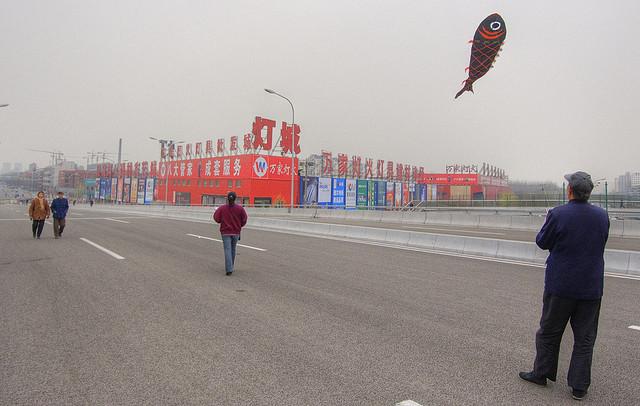Are there any people in the street?
Answer briefly. Yes. Where is this?
Write a very short answer. China. Is the fish in water?
Give a very brief answer. No. 